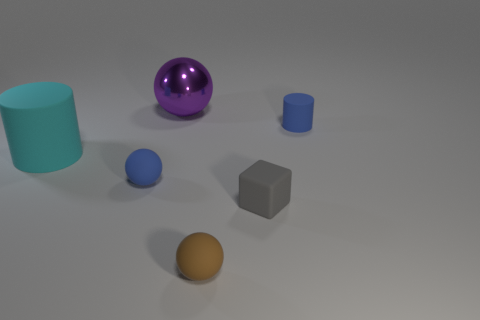Add 1 large metallic objects. How many objects exist? 7 Subtract all small matte balls. How many balls are left? 1 Subtract 2 cylinders. How many cylinders are left? 0 Subtract all brown balls. How many balls are left? 2 Subtract all cubes. How many objects are left? 5 Subtract all blue rubber things. Subtract all small gray blocks. How many objects are left? 3 Add 1 metal things. How many metal things are left? 2 Add 4 big cylinders. How many big cylinders exist? 5 Subtract 1 cyan cylinders. How many objects are left? 5 Subtract all blue cubes. Subtract all purple cylinders. How many cubes are left? 1 